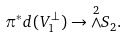<formula> <loc_0><loc_0><loc_500><loc_500>\pi ^ { * } d ( V _ { 1 } ^ { \bot } ) \rightarrow \overset { 2 } { \wedge } S _ { 2 } .</formula> 